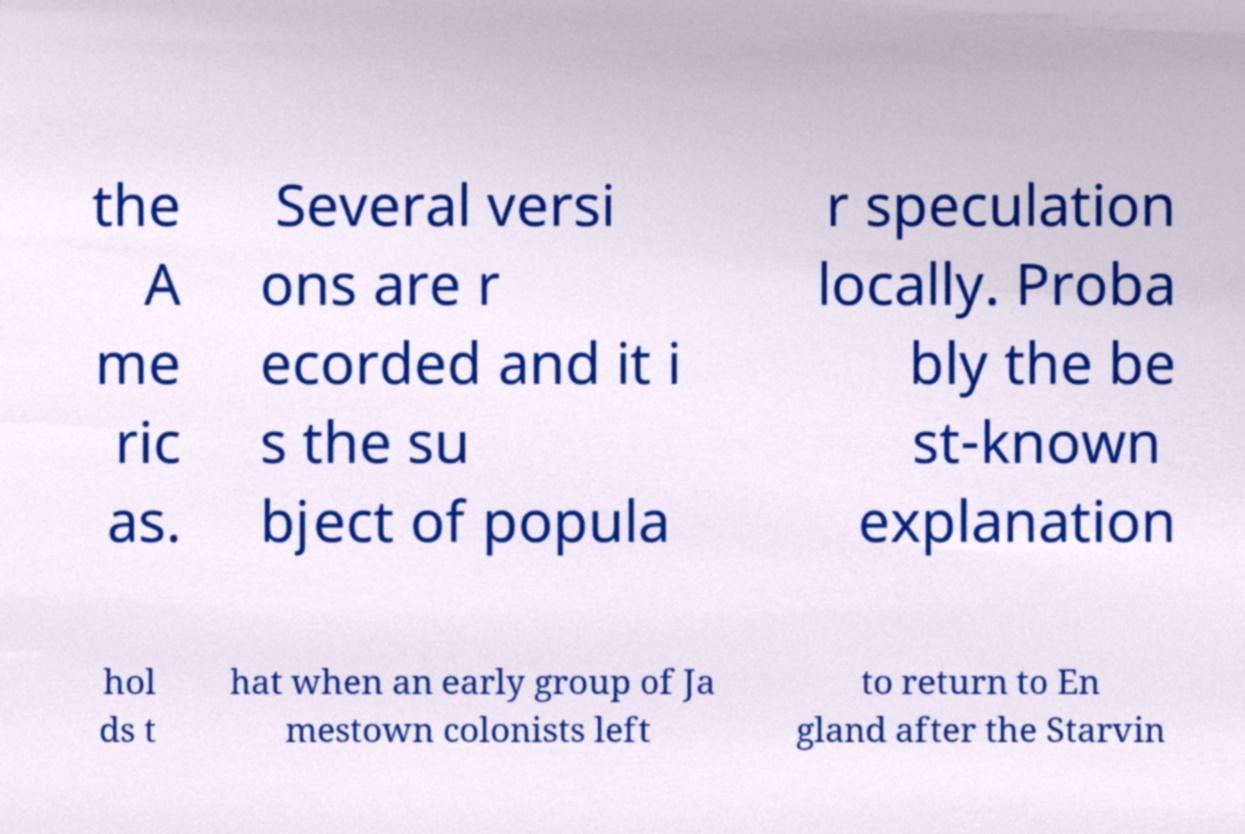What messages or text are displayed in this image? I need them in a readable, typed format. the A me ric as. Several versi ons are r ecorded and it i s the su bject of popula r speculation locally. Proba bly the be st-known explanation hol ds t hat when an early group of Ja mestown colonists left to return to En gland after the Starvin 